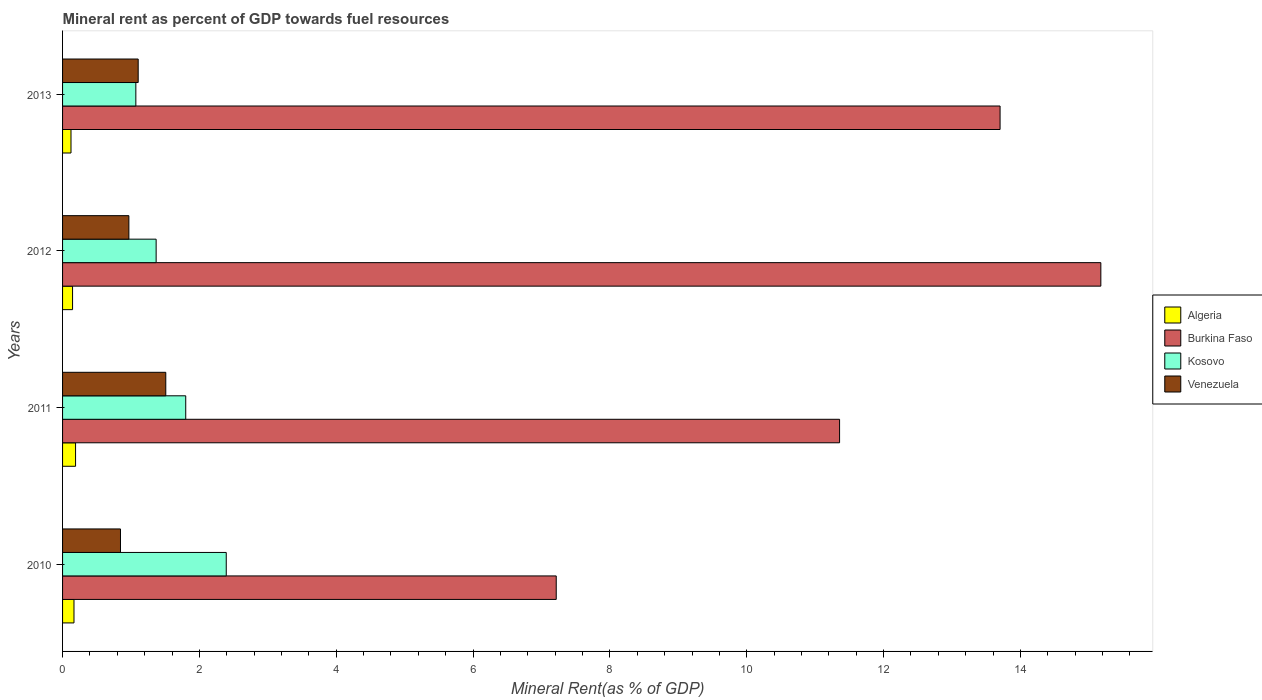How many groups of bars are there?
Make the answer very short. 4. How many bars are there on the 4th tick from the top?
Offer a terse response. 4. How many bars are there on the 3rd tick from the bottom?
Give a very brief answer. 4. What is the mineral rent in Burkina Faso in 2013?
Keep it short and to the point. 13.7. Across all years, what is the maximum mineral rent in Kosovo?
Your answer should be very brief. 2.39. Across all years, what is the minimum mineral rent in Venezuela?
Give a very brief answer. 0.85. In which year was the mineral rent in Kosovo minimum?
Give a very brief answer. 2013. What is the total mineral rent in Venezuela in the graph?
Keep it short and to the point. 4.43. What is the difference between the mineral rent in Algeria in 2010 and that in 2013?
Offer a very short reply. 0.04. What is the difference between the mineral rent in Burkina Faso in 2013 and the mineral rent in Kosovo in 2012?
Provide a short and direct response. 12.33. What is the average mineral rent in Venezuela per year?
Keep it short and to the point. 1.11. In the year 2010, what is the difference between the mineral rent in Burkina Faso and mineral rent in Algeria?
Your answer should be very brief. 7.05. In how many years, is the mineral rent in Kosovo greater than 7.6 %?
Make the answer very short. 0. What is the ratio of the mineral rent in Algeria in 2010 to that in 2013?
Your answer should be compact. 1.35. Is the mineral rent in Kosovo in 2010 less than that in 2013?
Offer a terse response. No. What is the difference between the highest and the second highest mineral rent in Algeria?
Provide a succinct answer. 0.02. What is the difference between the highest and the lowest mineral rent in Burkina Faso?
Your answer should be compact. 7.96. What does the 2nd bar from the top in 2011 represents?
Provide a short and direct response. Kosovo. What does the 2nd bar from the bottom in 2011 represents?
Make the answer very short. Burkina Faso. Is it the case that in every year, the sum of the mineral rent in Kosovo and mineral rent in Algeria is greater than the mineral rent in Venezuela?
Offer a terse response. Yes. Are all the bars in the graph horizontal?
Offer a terse response. Yes. How many years are there in the graph?
Offer a very short reply. 4. What is the difference between two consecutive major ticks on the X-axis?
Offer a very short reply. 2. Does the graph contain any zero values?
Ensure brevity in your answer.  No. What is the title of the graph?
Give a very brief answer. Mineral rent as percent of GDP towards fuel resources. What is the label or title of the X-axis?
Your answer should be compact. Mineral Rent(as % of GDP). What is the label or title of the Y-axis?
Offer a terse response. Years. What is the Mineral Rent(as % of GDP) of Algeria in 2010?
Provide a succinct answer. 0.17. What is the Mineral Rent(as % of GDP) in Burkina Faso in 2010?
Offer a very short reply. 7.22. What is the Mineral Rent(as % of GDP) of Kosovo in 2010?
Your response must be concise. 2.39. What is the Mineral Rent(as % of GDP) in Venezuela in 2010?
Give a very brief answer. 0.85. What is the Mineral Rent(as % of GDP) in Algeria in 2011?
Your response must be concise. 0.19. What is the Mineral Rent(as % of GDP) of Burkina Faso in 2011?
Your answer should be compact. 11.36. What is the Mineral Rent(as % of GDP) in Kosovo in 2011?
Your answer should be compact. 1.8. What is the Mineral Rent(as % of GDP) in Venezuela in 2011?
Give a very brief answer. 1.51. What is the Mineral Rent(as % of GDP) of Algeria in 2012?
Provide a succinct answer. 0.15. What is the Mineral Rent(as % of GDP) in Burkina Faso in 2012?
Ensure brevity in your answer.  15.18. What is the Mineral Rent(as % of GDP) of Kosovo in 2012?
Provide a short and direct response. 1.37. What is the Mineral Rent(as % of GDP) of Venezuela in 2012?
Ensure brevity in your answer.  0.97. What is the Mineral Rent(as % of GDP) of Algeria in 2013?
Your answer should be compact. 0.12. What is the Mineral Rent(as % of GDP) in Burkina Faso in 2013?
Make the answer very short. 13.7. What is the Mineral Rent(as % of GDP) in Kosovo in 2013?
Your answer should be compact. 1.07. What is the Mineral Rent(as % of GDP) of Venezuela in 2013?
Your response must be concise. 1.11. Across all years, what is the maximum Mineral Rent(as % of GDP) in Algeria?
Ensure brevity in your answer.  0.19. Across all years, what is the maximum Mineral Rent(as % of GDP) of Burkina Faso?
Make the answer very short. 15.18. Across all years, what is the maximum Mineral Rent(as % of GDP) of Kosovo?
Make the answer very short. 2.39. Across all years, what is the maximum Mineral Rent(as % of GDP) in Venezuela?
Provide a short and direct response. 1.51. Across all years, what is the minimum Mineral Rent(as % of GDP) in Algeria?
Keep it short and to the point. 0.12. Across all years, what is the minimum Mineral Rent(as % of GDP) in Burkina Faso?
Ensure brevity in your answer.  7.22. Across all years, what is the minimum Mineral Rent(as % of GDP) in Kosovo?
Give a very brief answer. 1.07. Across all years, what is the minimum Mineral Rent(as % of GDP) of Venezuela?
Your response must be concise. 0.85. What is the total Mineral Rent(as % of GDP) in Algeria in the graph?
Give a very brief answer. 0.63. What is the total Mineral Rent(as % of GDP) in Burkina Faso in the graph?
Keep it short and to the point. 47.45. What is the total Mineral Rent(as % of GDP) in Kosovo in the graph?
Provide a short and direct response. 6.63. What is the total Mineral Rent(as % of GDP) of Venezuela in the graph?
Make the answer very short. 4.43. What is the difference between the Mineral Rent(as % of GDP) of Algeria in 2010 and that in 2011?
Offer a terse response. -0.02. What is the difference between the Mineral Rent(as % of GDP) in Burkina Faso in 2010 and that in 2011?
Keep it short and to the point. -4.14. What is the difference between the Mineral Rent(as % of GDP) in Kosovo in 2010 and that in 2011?
Make the answer very short. 0.59. What is the difference between the Mineral Rent(as % of GDP) of Venezuela in 2010 and that in 2011?
Provide a short and direct response. -0.66. What is the difference between the Mineral Rent(as % of GDP) in Algeria in 2010 and that in 2012?
Ensure brevity in your answer.  0.02. What is the difference between the Mineral Rent(as % of GDP) in Burkina Faso in 2010 and that in 2012?
Offer a terse response. -7.96. What is the difference between the Mineral Rent(as % of GDP) of Kosovo in 2010 and that in 2012?
Your answer should be very brief. 1.02. What is the difference between the Mineral Rent(as % of GDP) in Venezuela in 2010 and that in 2012?
Your answer should be compact. -0.12. What is the difference between the Mineral Rent(as % of GDP) in Algeria in 2010 and that in 2013?
Your answer should be very brief. 0.04. What is the difference between the Mineral Rent(as % of GDP) of Burkina Faso in 2010 and that in 2013?
Provide a succinct answer. -6.49. What is the difference between the Mineral Rent(as % of GDP) of Kosovo in 2010 and that in 2013?
Offer a very short reply. 1.32. What is the difference between the Mineral Rent(as % of GDP) in Venezuela in 2010 and that in 2013?
Your response must be concise. -0.26. What is the difference between the Mineral Rent(as % of GDP) in Algeria in 2011 and that in 2012?
Keep it short and to the point. 0.04. What is the difference between the Mineral Rent(as % of GDP) of Burkina Faso in 2011 and that in 2012?
Offer a very short reply. -3.82. What is the difference between the Mineral Rent(as % of GDP) of Kosovo in 2011 and that in 2012?
Give a very brief answer. 0.43. What is the difference between the Mineral Rent(as % of GDP) of Venezuela in 2011 and that in 2012?
Offer a very short reply. 0.54. What is the difference between the Mineral Rent(as % of GDP) in Algeria in 2011 and that in 2013?
Offer a very short reply. 0.07. What is the difference between the Mineral Rent(as % of GDP) of Burkina Faso in 2011 and that in 2013?
Provide a short and direct response. -2.35. What is the difference between the Mineral Rent(as % of GDP) of Kosovo in 2011 and that in 2013?
Make the answer very short. 0.73. What is the difference between the Mineral Rent(as % of GDP) in Venezuela in 2011 and that in 2013?
Provide a short and direct response. 0.4. What is the difference between the Mineral Rent(as % of GDP) of Algeria in 2012 and that in 2013?
Ensure brevity in your answer.  0.02. What is the difference between the Mineral Rent(as % of GDP) in Burkina Faso in 2012 and that in 2013?
Your answer should be very brief. 1.47. What is the difference between the Mineral Rent(as % of GDP) in Kosovo in 2012 and that in 2013?
Keep it short and to the point. 0.3. What is the difference between the Mineral Rent(as % of GDP) of Venezuela in 2012 and that in 2013?
Offer a very short reply. -0.14. What is the difference between the Mineral Rent(as % of GDP) in Algeria in 2010 and the Mineral Rent(as % of GDP) in Burkina Faso in 2011?
Make the answer very short. -11.19. What is the difference between the Mineral Rent(as % of GDP) in Algeria in 2010 and the Mineral Rent(as % of GDP) in Kosovo in 2011?
Your response must be concise. -1.63. What is the difference between the Mineral Rent(as % of GDP) of Algeria in 2010 and the Mineral Rent(as % of GDP) of Venezuela in 2011?
Offer a very short reply. -1.34. What is the difference between the Mineral Rent(as % of GDP) in Burkina Faso in 2010 and the Mineral Rent(as % of GDP) in Kosovo in 2011?
Give a very brief answer. 5.42. What is the difference between the Mineral Rent(as % of GDP) in Burkina Faso in 2010 and the Mineral Rent(as % of GDP) in Venezuela in 2011?
Provide a short and direct response. 5.71. What is the difference between the Mineral Rent(as % of GDP) in Kosovo in 2010 and the Mineral Rent(as % of GDP) in Venezuela in 2011?
Ensure brevity in your answer.  0.88. What is the difference between the Mineral Rent(as % of GDP) of Algeria in 2010 and the Mineral Rent(as % of GDP) of Burkina Faso in 2012?
Offer a very short reply. -15.01. What is the difference between the Mineral Rent(as % of GDP) of Algeria in 2010 and the Mineral Rent(as % of GDP) of Kosovo in 2012?
Provide a short and direct response. -1.2. What is the difference between the Mineral Rent(as % of GDP) in Algeria in 2010 and the Mineral Rent(as % of GDP) in Venezuela in 2012?
Offer a very short reply. -0.8. What is the difference between the Mineral Rent(as % of GDP) in Burkina Faso in 2010 and the Mineral Rent(as % of GDP) in Kosovo in 2012?
Give a very brief answer. 5.85. What is the difference between the Mineral Rent(as % of GDP) in Burkina Faso in 2010 and the Mineral Rent(as % of GDP) in Venezuela in 2012?
Keep it short and to the point. 6.25. What is the difference between the Mineral Rent(as % of GDP) of Kosovo in 2010 and the Mineral Rent(as % of GDP) of Venezuela in 2012?
Make the answer very short. 1.42. What is the difference between the Mineral Rent(as % of GDP) of Algeria in 2010 and the Mineral Rent(as % of GDP) of Burkina Faso in 2013?
Provide a short and direct response. -13.54. What is the difference between the Mineral Rent(as % of GDP) in Algeria in 2010 and the Mineral Rent(as % of GDP) in Kosovo in 2013?
Your answer should be very brief. -0.9. What is the difference between the Mineral Rent(as % of GDP) of Algeria in 2010 and the Mineral Rent(as % of GDP) of Venezuela in 2013?
Provide a short and direct response. -0.94. What is the difference between the Mineral Rent(as % of GDP) in Burkina Faso in 2010 and the Mineral Rent(as % of GDP) in Kosovo in 2013?
Your answer should be compact. 6.14. What is the difference between the Mineral Rent(as % of GDP) in Burkina Faso in 2010 and the Mineral Rent(as % of GDP) in Venezuela in 2013?
Your answer should be compact. 6.11. What is the difference between the Mineral Rent(as % of GDP) of Kosovo in 2010 and the Mineral Rent(as % of GDP) of Venezuela in 2013?
Offer a very short reply. 1.29. What is the difference between the Mineral Rent(as % of GDP) in Algeria in 2011 and the Mineral Rent(as % of GDP) in Burkina Faso in 2012?
Keep it short and to the point. -14.99. What is the difference between the Mineral Rent(as % of GDP) of Algeria in 2011 and the Mineral Rent(as % of GDP) of Kosovo in 2012?
Offer a terse response. -1.18. What is the difference between the Mineral Rent(as % of GDP) in Algeria in 2011 and the Mineral Rent(as % of GDP) in Venezuela in 2012?
Provide a succinct answer. -0.78. What is the difference between the Mineral Rent(as % of GDP) in Burkina Faso in 2011 and the Mineral Rent(as % of GDP) in Kosovo in 2012?
Provide a succinct answer. 9.99. What is the difference between the Mineral Rent(as % of GDP) in Burkina Faso in 2011 and the Mineral Rent(as % of GDP) in Venezuela in 2012?
Your answer should be very brief. 10.39. What is the difference between the Mineral Rent(as % of GDP) of Kosovo in 2011 and the Mineral Rent(as % of GDP) of Venezuela in 2012?
Your response must be concise. 0.83. What is the difference between the Mineral Rent(as % of GDP) in Algeria in 2011 and the Mineral Rent(as % of GDP) in Burkina Faso in 2013?
Make the answer very short. -13.51. What is the difference between the Mineral Rent(as % of GDP) of Algeria in 2011 and the Mineral Rent(as % of GDP) of Kosovo in 2013?
Keep it short and to the point. -0.88. What is the difference between the Mineral Rent(as % of GDP) of Algeria in 2011 and the Mineral Rent(as % of GDP) of Venezuela in 2013?
Your answer should be very brief. -0.92. What is the difference between the Mineral Rent(as % of GDP) in Burkina Faso in 2011 and the Mineral Rent(as % of GDP) in Kosovo in 2013?
Your answer should be compact. 10.29. What is the difference between the Mineral Rent(as % of GDP) in Burkina Faso in 2011 and the Mineral Rent(as % of GDP) in Venezuela in 2013?
Ensure brevity in your answer.  10.25. What is the difference between the Mineral Rent(as % of GDP) of Kosovo in 2011 and the Mineral Rent(as % of GDP) of Venezuela in 2013?
Keep it short and to the point. 0.69. What is the difference between the Mineral Rent(as % of GDP) of Algeria in 2012 and the Mineral Rent(as % of GDP) of Burkina Faso in 2013?
Make the answer very short. -13.56. What is the difference between the Mineral Rent(as % of GDP) in Algeria in 2012 and the Mineral Rent(as % of GDP) in Kosovo in 2013?
Your answer should be very brief. -0.92. What is the difference between the Mineral Rent(as % of GDP) in Algeria in 2012 and the Mineral Rent(as % of GDP) in Venezuela in 2013?
Ensure brevity in your answer.  -0.96. What is the difference between the Mineral Rent(as % of GDP) of Burkina Faso in 2012 and the Mineral Rent(as % of GDP) of Kosovo in 2013?
Offer a terse response. 14.1. What is the difference between the Mineral Rent(as % of GDP) in Burkina Faso in 2012 and the Mineral Rent(as % of GDP) in Venezuela in 2013?
Your answer should be compact. 14.07. What is the difference between the Mineral Rent(as % of GDP) of Kosovo in 2012 and the Mineral Rent(as % of GDP) of Venezuela in 2013?
Your answer should be very brief. 0.26. What is the average Mineral Rent(as % of GDP) of Algeria per year?
Offer a terse response. 0.16. What is the average Mineral Rent(as % of GDP) of Burkina Faso per year?
Provide a succinct answer. 11.86. What is the average Mineral Rent(as % of GDP) of Kosovo per year?
Provide a succinct answer. 1.66. What is the average Mineral Rent(as % of GDP) of Venezuela per year?
Offer a very short reply. 1.11. In the year 2010, what is the difference between the Mineral Rent(as % of GDP) in Algeria and Mineral Rent(as % of GDP) in Burkina Faso?
Give a very brief answer. -7.05. In the year 2010, what is the difference between the Mineral Rent(as % of GDP) of Algeria and Mineral Rent(as % of GDP) of Kosovo?
Your response must be concise. -2.23. In the year 2010, what is the difference between the Mineral Rent(as % of GDP) in Algeria and Mineral Rent(as % of GDP) in Venezuela?
Offer a terse response. -0.68. In the year 2010, what is the difference between the Mineral Rent(as % of GDP) in Burkina Faso and Mineral Rent(as % of GDP) in Kosovo?
Provide a short and direct response. 4.82. In the year 2010, what is the difference between the Mineral Rent(as % of GDP) of Burkina Faso and Mineral Rent(as % of GDP) of Venezuela?
Offer a terse response. 6.37. In the year 2010, what is the difference between the Mineral Rent(as % of GDP) of Kosovo and Mineral Rent(as % of GDP) of Venezuela?
Offer a terse response. 1.55. In the year 2011, what is the difference between the Mineral Rent(as % of GDP) of Algeria and Mineral Rent(as % of GDP) of Burkina Faso?
Your response must be concise. -11.17. In the year 2011, what is the difference between the Mineral Rent(as % of GDP) in Algeria and Mineral Rent(as % of GDP) in Kosovo?
Offer a very short reply. -1.61. In the year 2011, what is the difference between the Mineral Rent(as % of GDP) of Algeria and Mineral Rent(as % of GDP) of Venezuela?
Provide a short and direct response. -1.32. In the year 2011, what is the difference between the Mineral Rent(as % of GDP) in Burkina Faso and Mineral Rent(as % of GDP) in Kosovo?
Keep it short and to the point. 9.56. In the year 2011, what is the difference between the Mineral Rent(as % of GDP) in Burkina Faso and Mineral Rent(as % of GDP) in Venezuela?
Give a very brief answer. 9.85. In the year 2011, what is the difference between the Mineral Rent(as % of GDP) of Kosovo and Mineral Rent(as % of GDP) of Venezuela?
Your answer should be very brief. 0.29. In the year 2012, what is the difference between the Mineral Rent(as % of GDP) in Algeria and Mineral Rent(as % of GDP) in Burkina Faso?
Offer a terse response. -15.03. In the year 2012, what is the difference between the Mineral Rent(as % of GDP) in Algeria and Mineral Rent(as % of GDP) in Kosovo?
Keep it short and to the point. -1.22. In the year 2012, what is the difference between the Mineral Rent(as % of GDP) in Algeria and Mineral Rent(as % of GDP) in Venezuela?
Your answer should be very brief. -0.82. In the year 2012, what is the difference between the Mineral Rent(as % of GDP) of Burkina Faso and Mineral Rent(as % of GDP) of Kosovo?
Provide a succinct answer. 13.81. In the year 2012, what is the difference between the Mineral Rent(as % of GDP) in Burkina Faso and Mineral Rent(as % of GDP) in Venezuela?
Your response must be concise. 14.21. In the year 2012, what is the difference between the Mineral Rent(as % of GDP) of Kosovo and Mineral Rent(as % of GDP) of Venezuela?
Your answer should be compact. 0.4. In the year 2013, what is the difference between the Mineral Rent(as % of GDP) in Algeria and Mineral Rent(as % of GDP) in Burkina Faso?
Provide a succinct answer. -13.58. In the year 2013, what is the difference between the Mineral Rent(as % of GDP) in Algeria and Mineral Rent(as % of GDP) in Kosovo?
Your answer should be very brief. -0.95. In the year 2013, what is the difference between the Mineral Rent(as % of GDP) of Algeria and Mineral Rent(as % of GDP) of Venezuela?
Offer a very short reply. -0.98. In the year 2013, what is the difference between the Mineral Rent(as % of GDP) in Burkina Faso and Mineral Rent(as % of GDP) in Kosovo?
Provide a short and direct response. 12.63. In the year 2013, what is the difference between the Mineral Rent(as % of GDP) in Burkina Faso and Mineral Rent(as % of GDP) in Venezuela?
Provide a succinct answer. 12.6. In the year 2013, what is the difference between the Mineral Rent(as % of GDP) in Kosovo and Mineral Rent(as % of GDP) in Venezuela?
Offer a terse response. -0.03. What is the ratio of the Mineral Rent(as % of GDP) of Algeria in 2010 to that in 2011?
Give a very brief answer. 0.88. What is the ratio of the Mineral Rent(as % of GDP) in Burkina Faso in 2010 to that in 2011?
Provide a succinct answer. 0.64. What is the ratio of the Mineral Rent(as % of GDP) in Kosovo in 2010 to that in 2011?
Keep it short and to the point. 1.33. What is the ratio of the Mineral Rent(as % of GDP) in Venezuela in 2010 to that in 2011?
Give a very brief answer. 0.56. What is the ratio of the Mineral Rent(as % of GDP) in Algeria in 2010 to that in 2012?
Make the answer very short. 1.14. What is the ratio of the Mineral Rent(as % of GDP) in Burkina Faso in 2010 to that in 2012?
Keep it short and to the point. 0.48. What is the ratio of the Mineral Rent(as % of GDP) in Kosovo in 2010 to that in 2012?
Offer a terse response. 1.75. What is the ratio of the Mineral Rent(as % of GDP) in Venezuela in 2010 to that in 2012?
Your answer should be very brief. 0.87. What is the ratio of the Mineral Rent(as % of GDP) of Algeria in 2010 to that in 2013?
Ensure brevity in your answer.  1.35. What is the ratio of the Mineral Rent(as % of GDP) of Burkina Faso in 2010 to that in 2013?
Provide a succinct answer. 0.53. What is the ratio of the Mineral Rent(as % of GDP) in Kosovo in 2010 to that in 2013?
Make the answer very short. 2.23. What is the ratio of the Mineral Rent(as % of GDP) of Venezuela in 2010 to that in 2013?
Your answer should be very brief. 0.77. What is the ratio of the Mineral Rent(as % of GDP) of Algeria in 2011 to that in 2012?
Your answer should be very brief. 1.3. What is the ratio of the Mineral Rent(as % of GDP) in Burkina Faso in 2011 to that in 2012?
Your response must be concise. 0.75. What is the ratio of the Mineral Rent(as % of GDP) of Kosovo in 2011 to that in 2012?
Your answer should be very brief. 1.32. What is the ratio of the Mineral Rent(as % of GDP) in Venezuela in 2011 to that in 2012?
Make the answer very short. 1.56. What is the ratio of the Mineral Rent(as % of GDP) in Algeria in 2011 to that in 2013?
Give a very brief answer. 1.54. What is the ratio of the Mineral Rent(as % of GDP) of Burkina Faso in 2011 to that in 2013?
Make the answer very short. 0.83. What is the ratio of the Mineral Rent(as % of GDP) of Kosovo in 2011 to that in 2013?
Your response must be concise. 1.68. What is the ratio of the Mineral Rent(as % of GDP) of Venezuela in 2011 to that in 2013?
Provide a succinct answer. 1.36. What is the ratio of the Mineral Rent(as % of GDP) of Algeria in 2012 to that in 2013?
Your answer should be compact. 1.19. What is the ratio of the Mineral Rent(as % of GDP) of Burkina Faso in 2012 to that in 2013?
Provide a short and direct response. 1.11. What is the ratio of the Mineral Rent(as % of GDP) in Kosovo in 2012 to that in 2013?
Provide a succinct answer. 1.28. What is the ratio of the Mineral Rent(as % of GDP) of Venezuela in 2012 to that in 2013?
Ensure brevity in your answer.  0.88. What is the difference between the highest and the second highest Mineral Rent(as % of GDP) in Algeria?
Keep it short and to the point. 0.02. What is the difference between the highest and the second highest Mineral Rent(as % of GDP) in Burkina Faso?
Keep it short and to the point. 1.47. What is the difference between the highest and the second highest Mineral Rent(as % of GDP) of Kosovo?
Keep it short and to the point. 0.59. What is the difference between the highest and the second highest Mineral Rent(as % of GDP) in Venezuela?
Your answer should be compact. 0.4. What is the difference between the highest and the lowest Mineral Rent(as % of GDP) of Algeria?
Ensure brevity in your answer.  0.07. What is the difference between the highest and the lowest Mineral Rent(as % of GDP) of Burkina Faso?
Ensure brevity in your answer.  7.96. What is the difference between the highest and the lowest Mineral Rent(as % of GDP) of Kosovo?
Offer a terse response. 1.32. What is the difference between the highest and the lowest Mineral Rent(as % of GDP) of Venezuela?
Your answer should be compact. 0.66. 